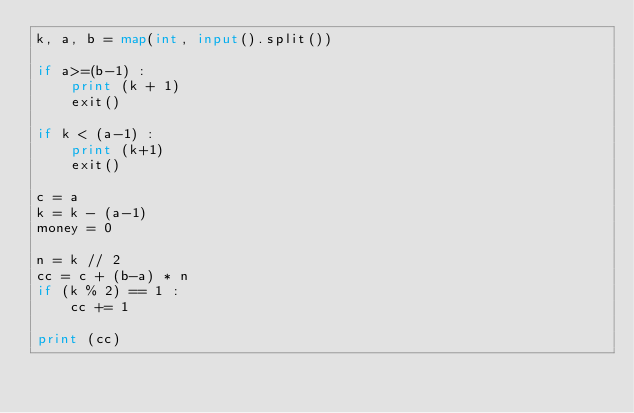<code> <loc_0><loc_0><loc_500><loc_500><_Python_>k, a, b = map(int, input().split())

if a>=(b-1) :
    print (k + 1)
    exit()

if k < (a-1) :
    print (k+1) 
    exit()

c = a
k = k - (a-1)
money = 0

n = k // 2
cc = c + (b-a) * n
if (k % 2) == 1 :
    cc += 1

print (cc)</code> 